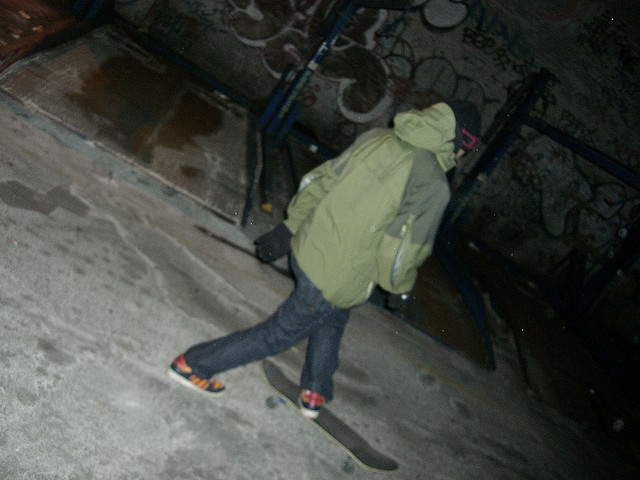<image>Is the man tired? It is unknown if the man is tired. It can be both yes or no. Is the man tired? I don't know if the man is tired. It is possible that he is tired, but it is also possible that he is not. 